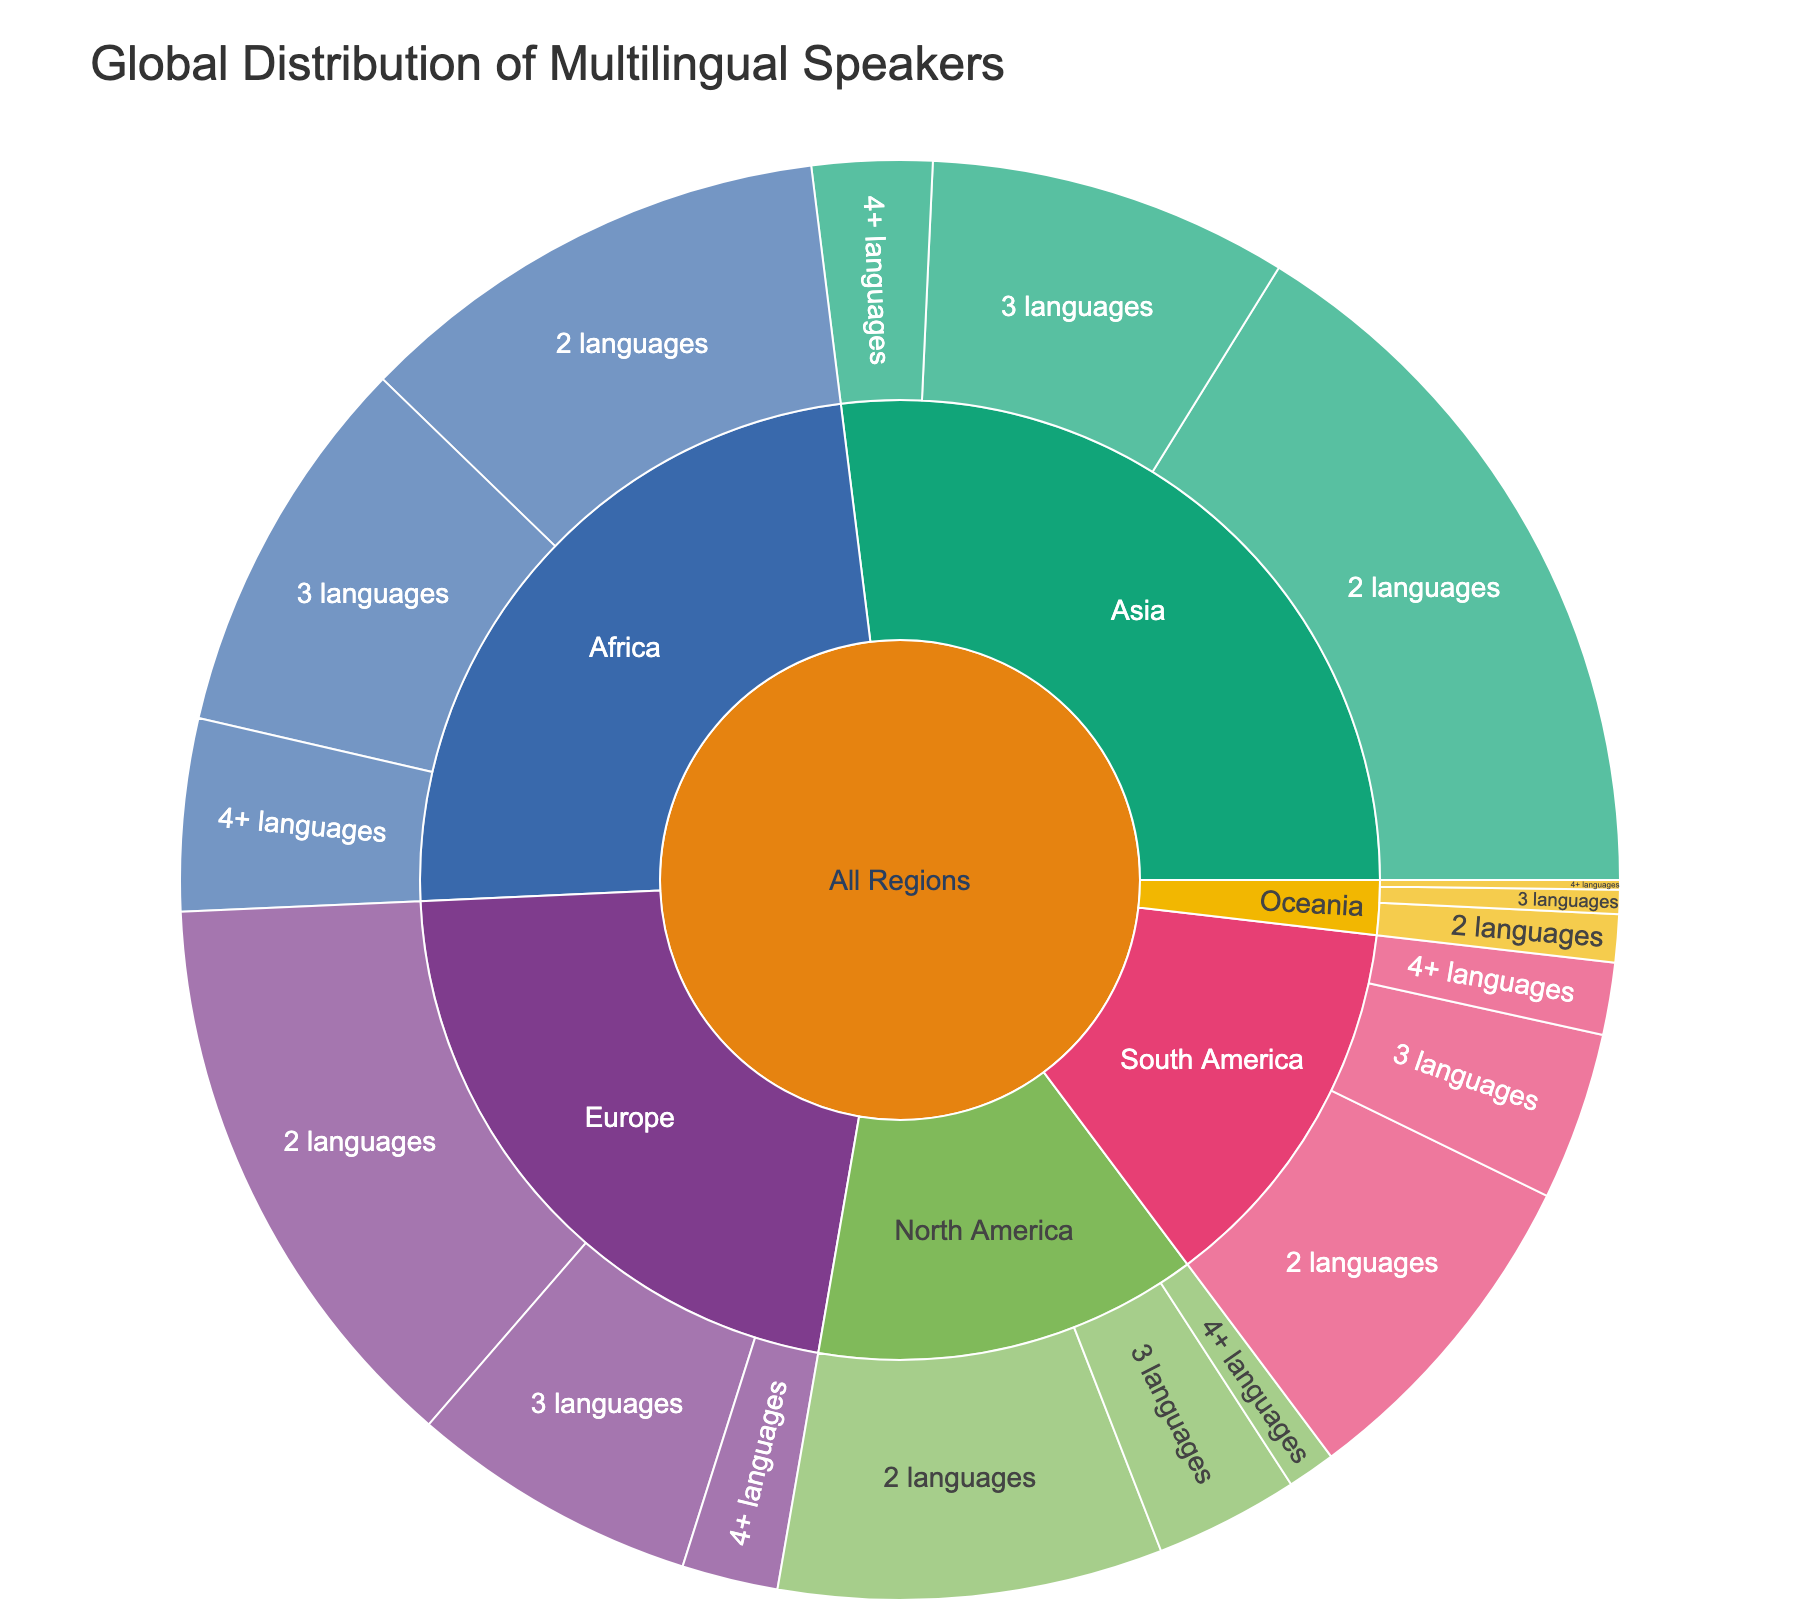Which region has the highest number of multilingual speakers? By looking at the outermost sections of the sunburst plot, we can compare the count of all multilingual speakers in each region: Asia (250,000,000), Europe (200,000,000), Africa (220,000,000), North America (120,000,000), South America (120,000,000), and Oceania (17,000,000). Asia has the highest total.
Answer: Asia How many speakers in Africa speak more than 2 languages? In the Africa region, the sunburst plot shows 80,000,000 for 3 languages and 40,000,000 for 4+ languages. Adding them gives 80,000,000 + 40,000,000 = 120,000,000 speakers.
Answer: 120,000,000 Which region has the lowest number of speakers who speak 4+ languages? By comparing the sections for "4+ languages" in each region, we see that Oceania has the smallest count with only 2,000,000 speakers.
Answer: Oceania What is the total number of speakers in Europe who speak exactly 2 languages? The sunburst plot shows that Europe has 120,000,000 speakers who speak 2 languages.
Answer: 120,000,000 How many more multilingual speakers are there in Asia compared to North America? Summing up all multilingual speakers: Asia has 150,000,000 + 75,000,000 + 25,000,000 = 250,000,000 and North America has 80,000,000 + 30,000,000 + 10,000,000 = 120,000,000. The difference is 250,000,000 - 120,000,000 = 130,000,000.
Answer: 130,000,000 How many multilingual speakers in South America speak 3 languages? The sunburst plot shows that South America has 35,000,000 speakers who speak 3 languages.
Answer: 35,000,000 Compare the number of multilingual speakers in Oceania who speak 2 languages to those who speak 4+ languages. Which group is bigger? Oceania has 10,000,000 speakers who speak 2 languages and 2,000,000 speakers who speak 4+ languages. The group of speakers who speak 2 languages is bigger.
Answer: 2 languages What is the sum of the multilingual speakers in North and South America who speak exactly 2 languages? Adding the numbers from the sunburst plot: North America has 80,000,000 and South America has 70,000,000. The sum is 80,000,000 + 70,000,000 = 150,000,000.
Answer: 150,000,000 Which region has more speakers who speak 3 languages, Africa or Europe? The sunburst plot shows that Africa has 80,000,000 speakers who speak 3 languages, while Europe has 60,000,000. Therefore, Africa has more speakers.
Answer: Africa 